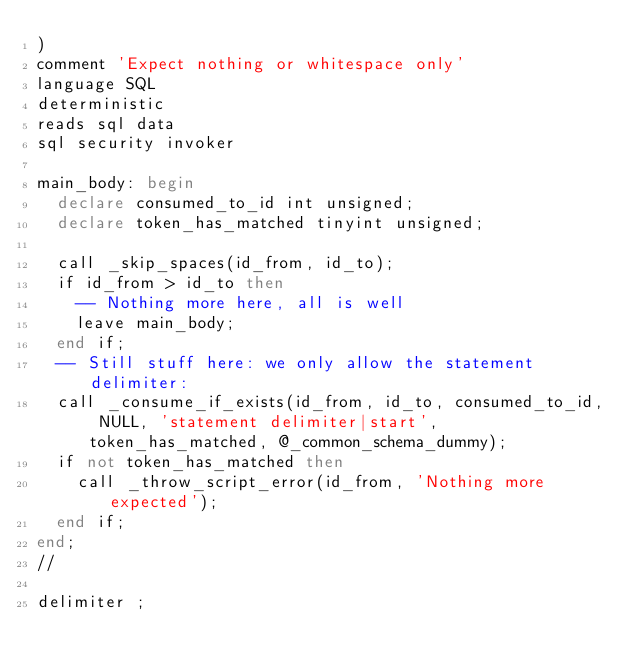<code> <loc_0><loc_0><loc_500><loc_500><_SQL_>) 
comment 'Expect nothing or whitespace only'
language SQL
deterministic
reads sql data
sql security invoker

main_body: begin
  declare consumed_to_id int unsigned;
  declare token_has_matched tinyint unsigned;

  call _skip_spaces(id_from, id_to);
  if id_from > id_to then
    -- Nothing more here, all is well
    leave main_body;
  end if;
  -- Still stuff here: we only allow the statement delimiter:
  call _consume_if_exists(id_from, id_to, consumed_to_id, NULL, 'statement delimiter|start', token_has_matched, @_common_schema_dummy);
  if not token_has_matched then
    call _throw_script_error(id_from, 'Nothing more expected');
  end if;
end;
//

delimiter ;
</code> 